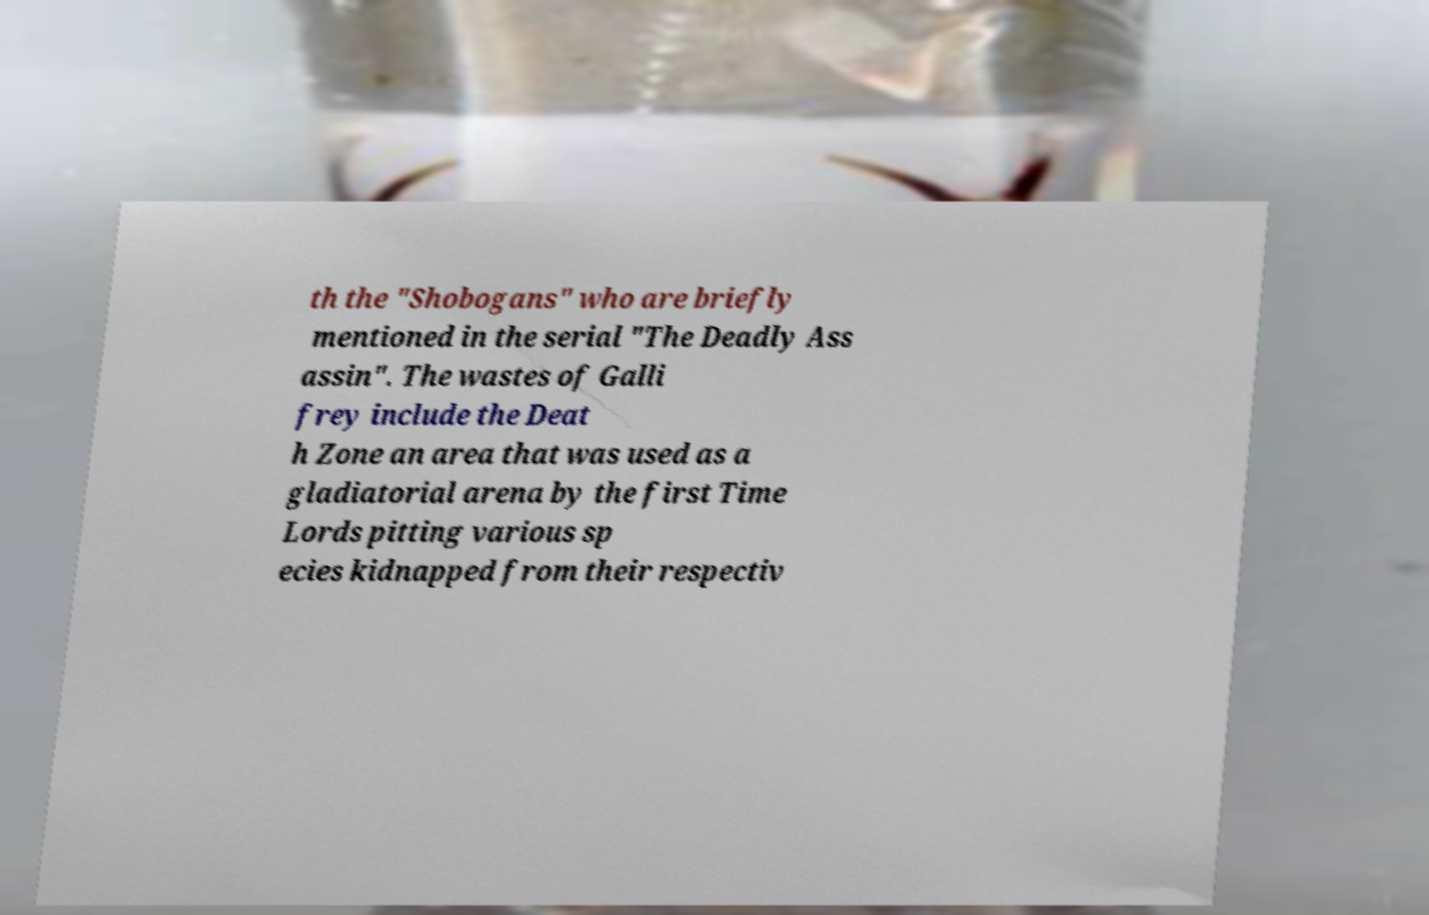There's text embedded in this image that I need extracted. Can you transcribe it verbatim? th the "Shobogans" who are briefly mentioned in the serial "The Deadly Ass assin". The wastes of Galli frey include the Deat h Zone an area that was used as a gladiatorial arena by the first Time Lords pitting various sp ecies kidnapped from their respectiv 